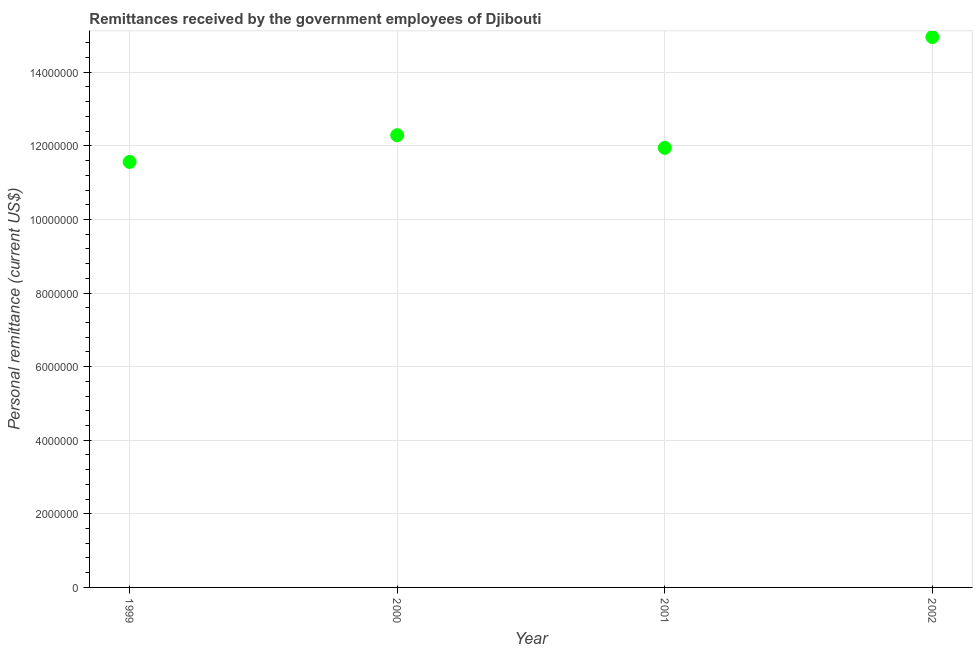What is the personal remittances in 2000?
Offer a terse response. 1.23e+07. Across all years, what is the maximum personal remittances?
Your answer should be compact. 1.50e+07. Across all years, what is the minimum personal remittances?
Keep it short and to the point. 1.16e+07. In which year was the personal remittances maximum?
Your response must be concise. 2002. In which year was the personal remittances minimum?
Your response must be concise. 1999. What is the sum of the personal remittances?
Offer a terse response. 5.08e+07. What is the difference between the personal remittances in 1999 and 2001?
Your answer should be very brief. -3.83e+05. What is the average personal remittances per year?
Offer a terse response. 1.27e+07. What is the median personal remittances?
Your answer should be compact. 1.21e+07. In how many years, is the personal remittances greater than 12400000 US$?
Your answer should be very brief. 1. Do a majority of the years between 2002 and 1999 (inclusive) have personal remittances greater than 4800000 US$?
Provide a short and direct response. Yes. What is the ratio of the personal remittances in 1999 to that in 2001?
Give a very brief answer. 0.97. Is the personal remittances in 1999 less than that in 2001?
Offer a very short reply. Yes. What is the difference between the highest and the second highest personal remittances?
Provide a short and direct response. 2.67e+06. What is the difference between the highest and the lowest personal remittances?
Make the answer very short. 3.39e+06. In how many years, is the personal remittances greater than the average personal remittances taken over all years?
Give a very brief answer. 1. How many dotlines are there?
Your answer should be compact. 1. Are the values on the major ticks of Y-axis written in scientific E-notation?
Your response must be concise. No. Does the graph contain grids?
Offer a terse response. Yes. What is the title of the graph?
Offer a terse response. Remittances received by the government employees of Djibouti. What is the label or title of the X-axis?
Ensure brevity in your answer.  Year. What is the label or title of the Y-axis?
Your answer should be compact. Personal remittance (current US$). What is the Personal remittance (current US$) in 1999?
Your response must be concise. 1.16e+07. What is the Personal remittance (current US$) in 2000?
Offer a very short reply. 1.23e+07. What is the Personal remittance (current US$) in 2001?
Keep it short and to the point. 1.19e+07. What is the Personal remittance (current US$) in 2002?
Keep it short and to the point. 1.50e+07. What is the difference between the Personal remittance (current US$) in 1999 and 2000?
Give a very brief answer. -7.26e+05. What is the difference between the Personal remittance (current US$) in 1999 and 2001?
Offer a very short reply. -3.83e+05. What is the difference between the Personal remittance (current US$) in 1999 and 2002?
Provide a short and direct response. -3.39e+06. What is the difference between the Personal remittance (current US$) in 2000 and 2001?
Give a very brief answer. 3.43e+05. What is the difference between the Personal remittance (current US$) in 2000 and 2002?
Your response must be concise. -2.67e+06. What is the difference between the Personal remittance (current US$) in 2001 and 2002?
Provide a succinct answer. -3.01e+06. What is the ratio of the Personal remittance (current US$) in 1999 to that in 2000?
Offer a terse response. 0.94. What is the ratio of the Personal remittance (current US$) in 1999 to that in 2002?
Give a very brief answer. 0.77. What is the ratio of the Personal remittance (current US$) in 2000 to that in 2001?
Your answer should be very brief. 1.03. What is the ratio of the Personal remittance (current US$) in 2000 to that in 2002?
Provide a short and direct response. 0.82. What is the ratio of the Personal remittance (current US$) in 2001 to that in 2002?
Your response must be concise. 0.8. 